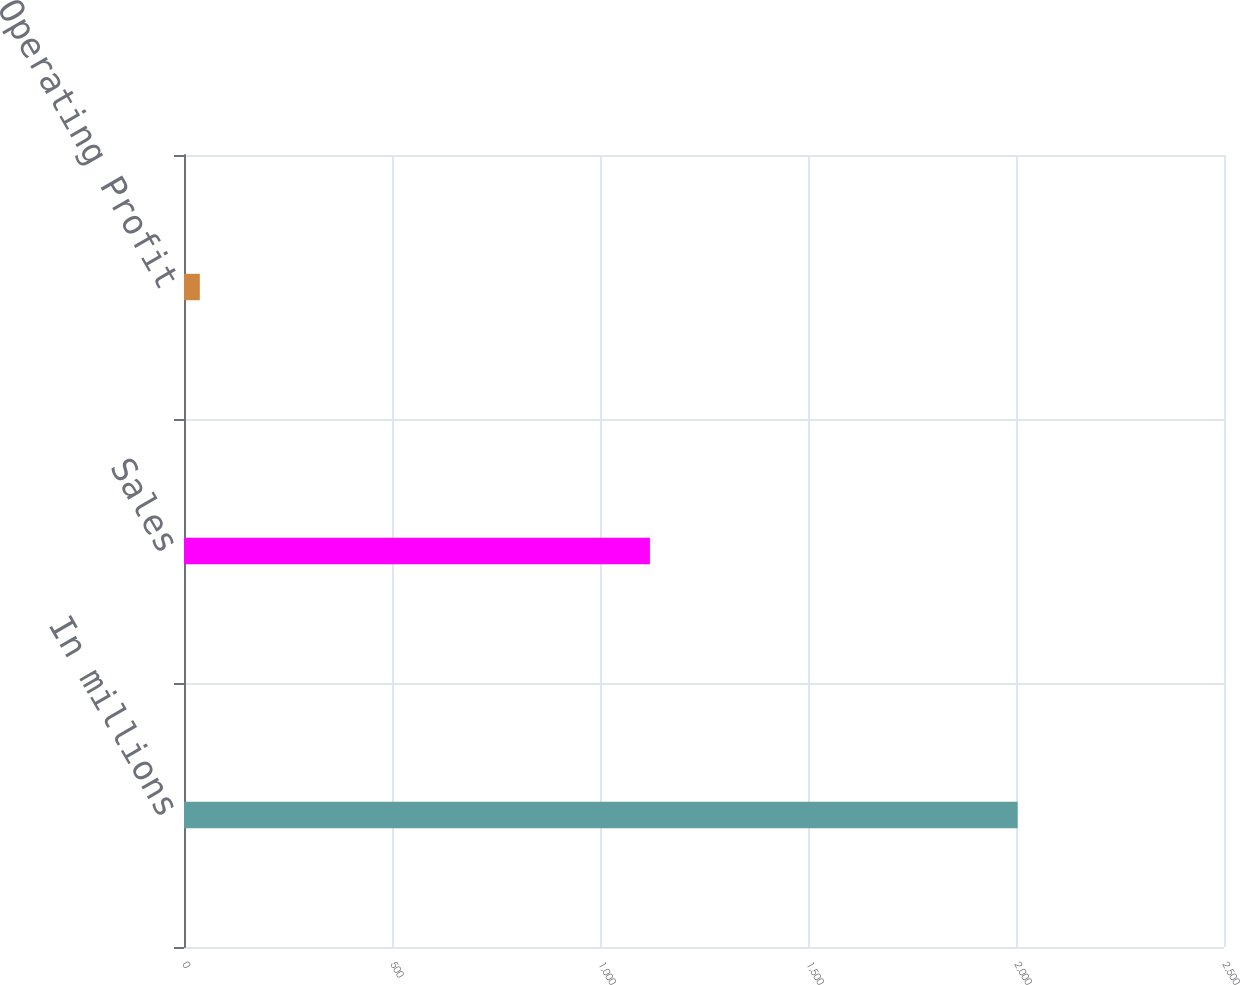Convert chart to OTSL. <chart><loc_0><loc_0><loc_500><loc_500><bar_chart><fcel>In millions<fcel>Sales<fcel>Operating Profit<nl><fcel>2004<fcel>1120<fcel>38<nl></chart> 